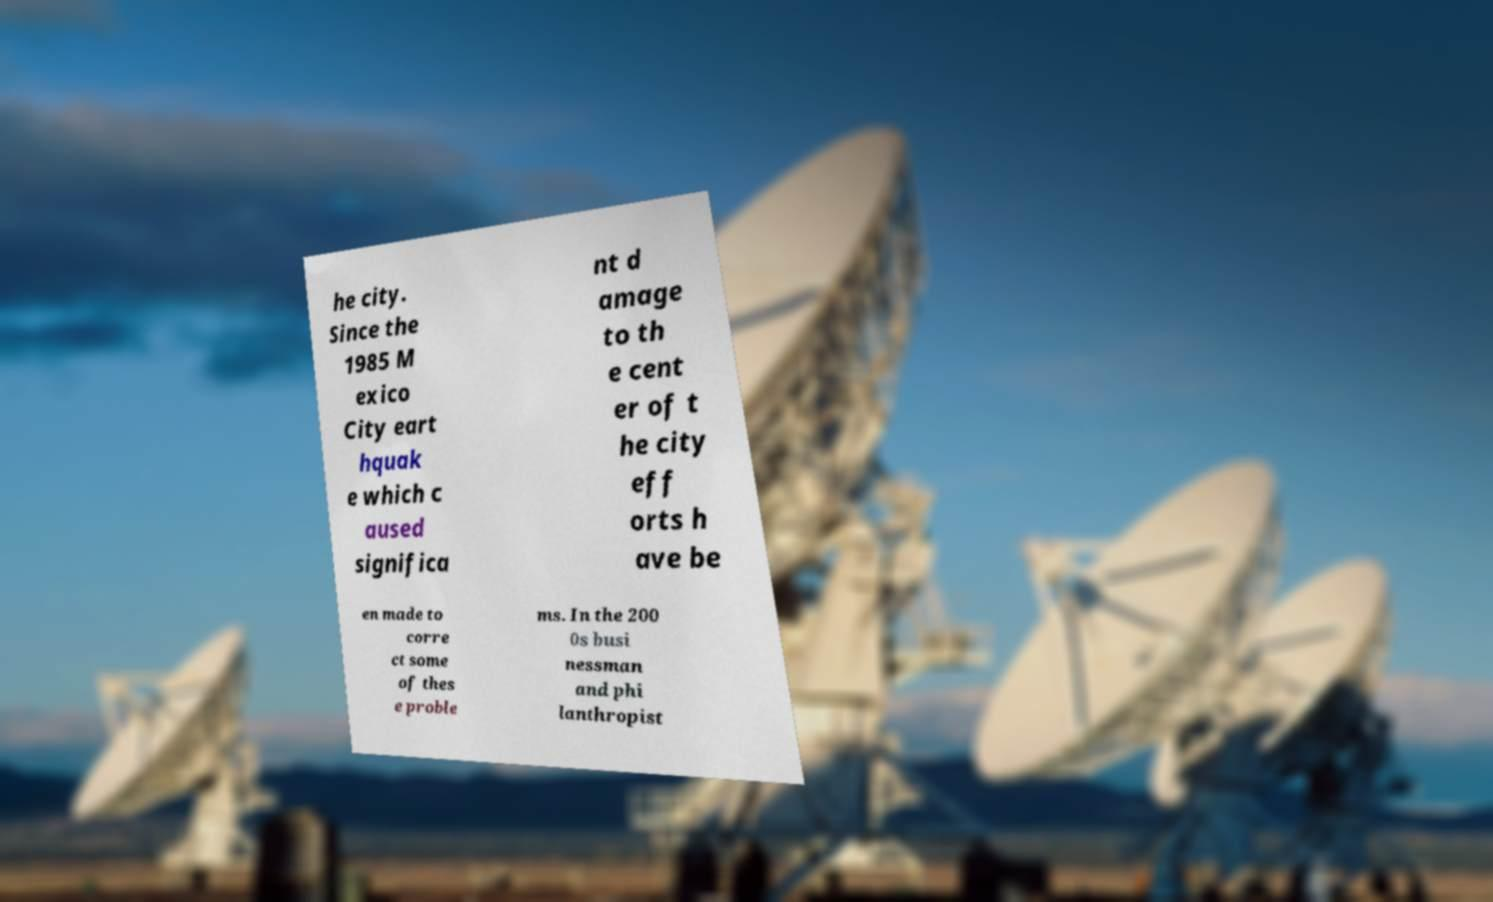There's text embedded in this image that I need extracted. Can you transcribe it verbatim? he city. Since the 1985 M exico City eart hquak e which c aused significa nt d amage to th e cent er of t he city eff orts h ave be en made to corre ct some of thes e proble ms. In the 200 0s busi nessman and phi lanthropist 